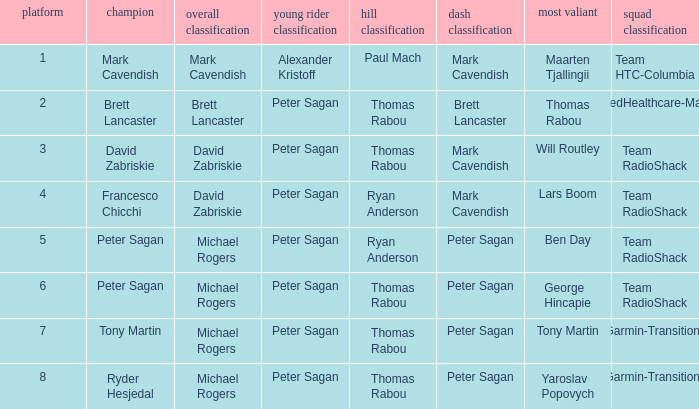When Peter Sagan won the youth classification and Thomas Rabou won the most corageous, who won the sprint classification? Brett Lancaster. Could you help me parse every detail presented in this table? {'header': ['platform', 'champion', 'overall classification', 'young rider classification', 'hill classification', 'dash classification', 'most valiant', 'squad classification'], 'rows': [['1', 'Mark Cavendish', 'Mark Cavendish', 'Alexander Kristoff', 'Paul Mach', 'Mark Cavendish', 'Maarten Tjallingii', 'Team HTC-Columbia'], ['2', 'Brett Lancaster', 'Brett Lancaster', 'Peter Sagan', 'Thomas Rabou', 'Brett Lancaster', 'Thomas Rabou', 'UnitedHealthcare-Maxxis'], ['3', 'David Zabriskie', 'David Zabriskie', 'Peter Sagan', 'Thomas Rabou', 'Mark Cavendish', 'Will Routley', 'Team RadioShack'], ['4', 'Francesco Chicchi', 'David Zabriskie', 'Peter Sagan', 'Ryan Anderson', 'Mark Cavendish', 'Lars Boom', 'Team RadioShack'], ['5', 'Peter Sagan', 'Michael Rogers', 'Peter Sagan', 'Ryan Anderson', 'Peter Sagan', 'Ben Day', 'Team RadioShack'], ['6', 'Peter Sagan', 'Michael Rogers', 'Peter Sagan', 'Thomas Rabou', 'Peter Sagan', 'George Hincapie', 'Team RadioShack'], ['7', 'Tony Martin', 'Michael Rogers', 'Peter Sagan', 'Thomas Rabou', 'Peter Sagan', 'Tony Martin', 'Garmin-Transitions'], ['8', 'Ryder Hesjedal', 'Michael Rogers', 'Peter Sagan', 'Thomas Rabou', 'Peter Sagan', 'Yaroslav Popovych', 'Garmin-Transitions']]} 